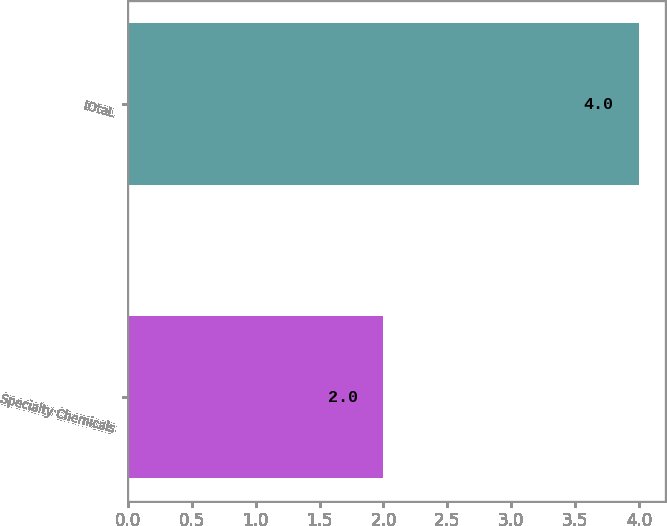Convert chart. <chart><loc_0><loc_0><loc_500><loc_500><bar_chart><fcel>Specialty Chemicals<fcel>tOtaL<nl><fcel>2<fcel>4<nl></chart> 